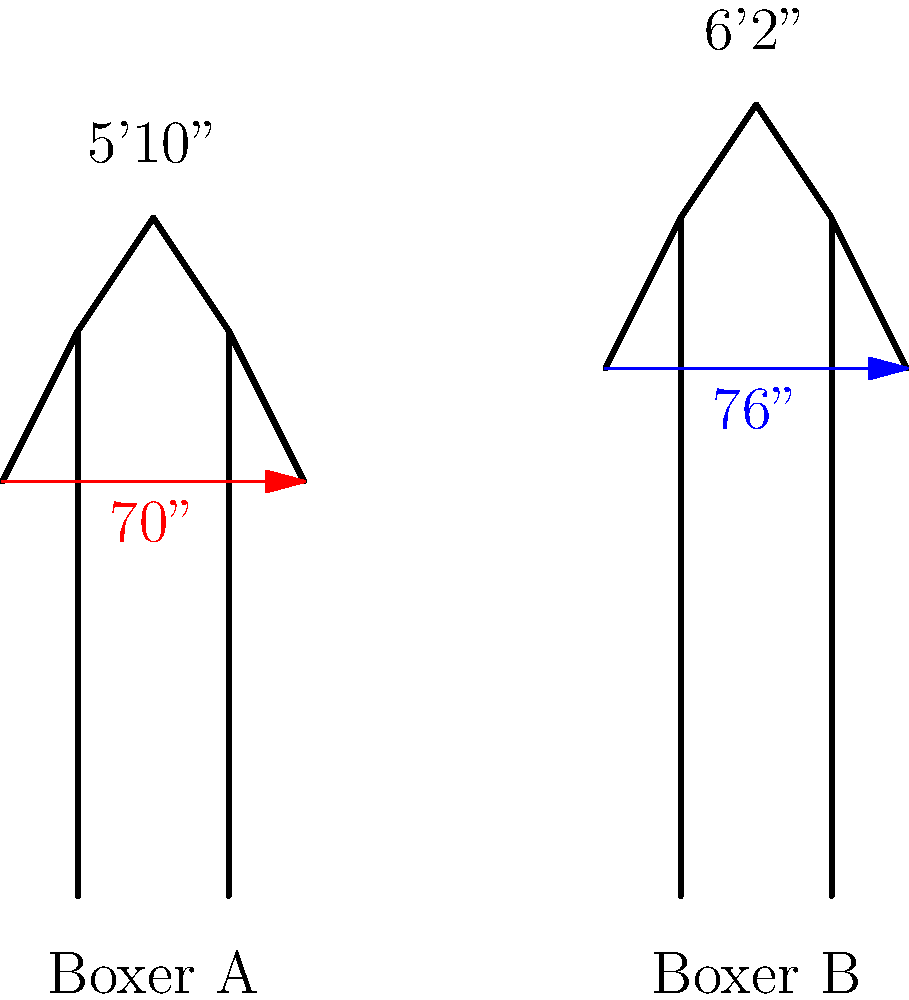In this side-by-side comparison of two boxers, Boxer A stands at 5'10" with a 70" reach, while Boxer B is 6'2" with a 76" reach. What is the difference in their reach advantage relative to their height difference? To solve this problem, we need to follow these steps:

1. Calculate the height difference:
   Boxer B's height: 6'2" = 74"
   Boxer A's height: 5'10" = 70"
   Height difference: 74" - 70" = 4"

2. Calculate the reach difference:
   Boxer B's reach: 76"
   Boxer A's reach: 70"
   Reach difference: 76" - 70" = 6"

3. Compare the reach difference to the height difference:
   The reach difference (6") is 2" more than the height difference (4").

This means that Boxer B's reach advantage is 2" greater than what would be expected based solely on the height difference. In combat sports, this additional reach advantage can be significant, potentially allowing Boxer B to strike from a distance while staying out of Boxer A's range.
Answer: 2 inches 